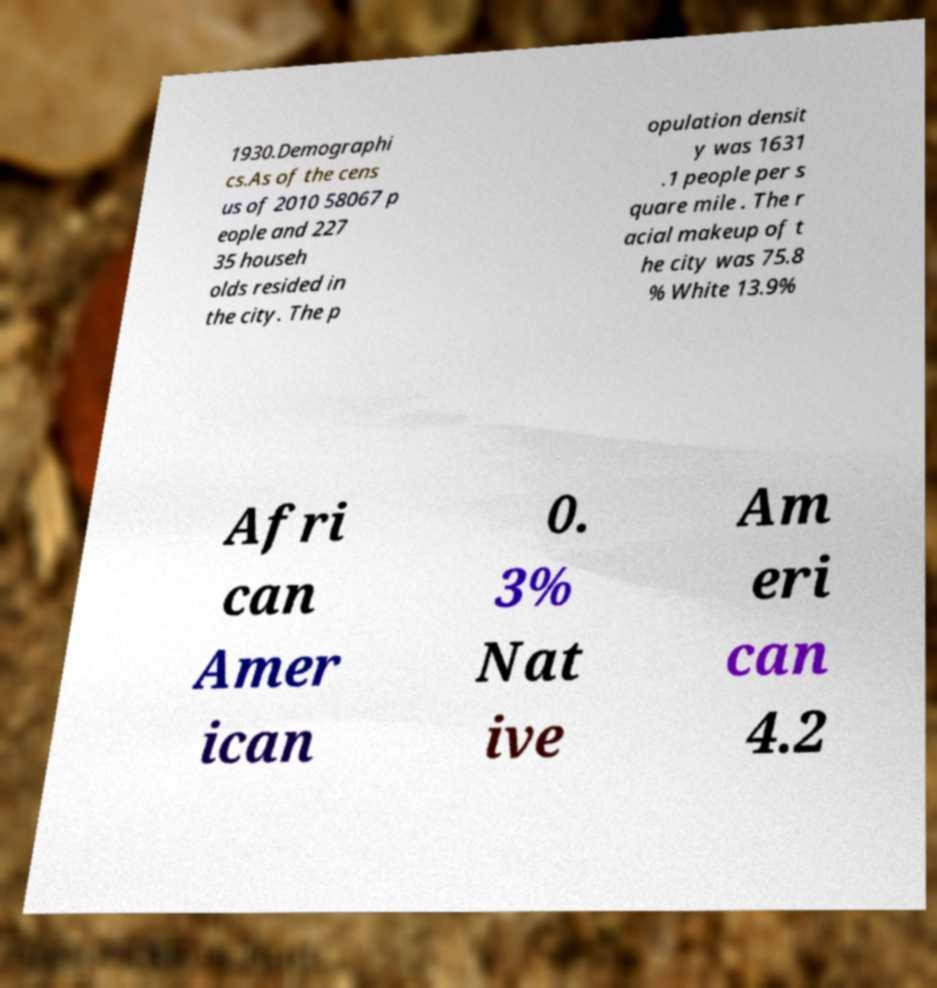I need the written content from this picture converted into text. Can you do that? 1930.Demographi cs.As of the cens us of 2010 58067 p eople and 227 35 househ olds resided in the city. The p opulation densit y was 1631 .1 people per s quare mile . The r acial makeup of t he city was 75.8 % White 13.9% Afri can Amer ican 0. 3% Nat ive Am eri can 4.2 